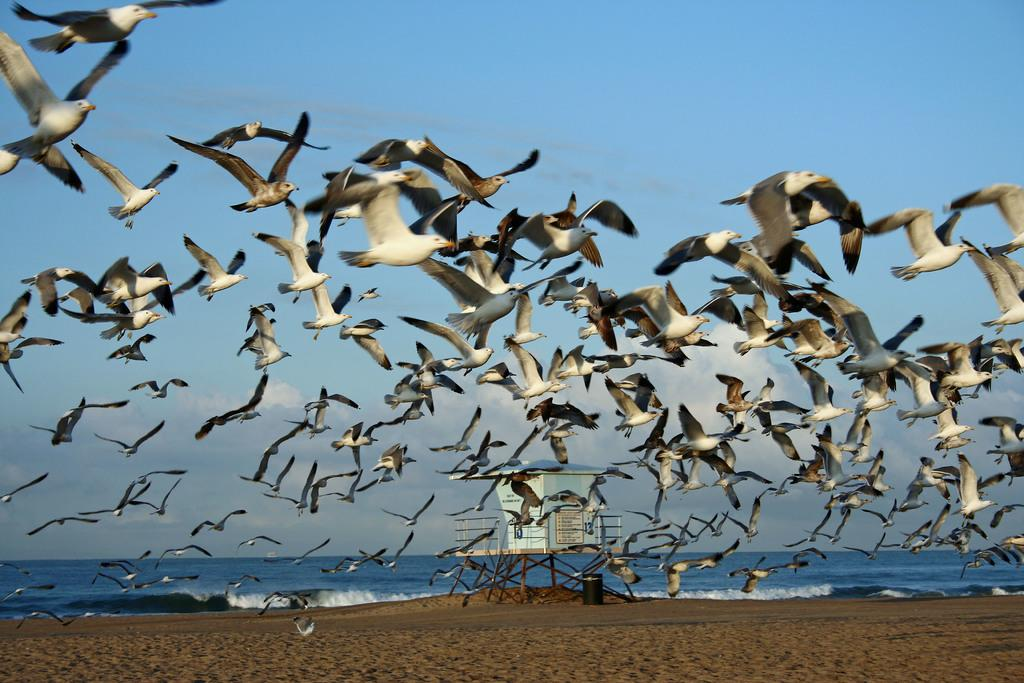What is happening in the sky in the image? There are birds flying in the air in the image. What can be seen in the background of the image? There is water visible in the background of the image. What type of cloth is being used to cover the men in the image? There are no men or cloth present in the image; it features birds flying in the air and water in the background. 